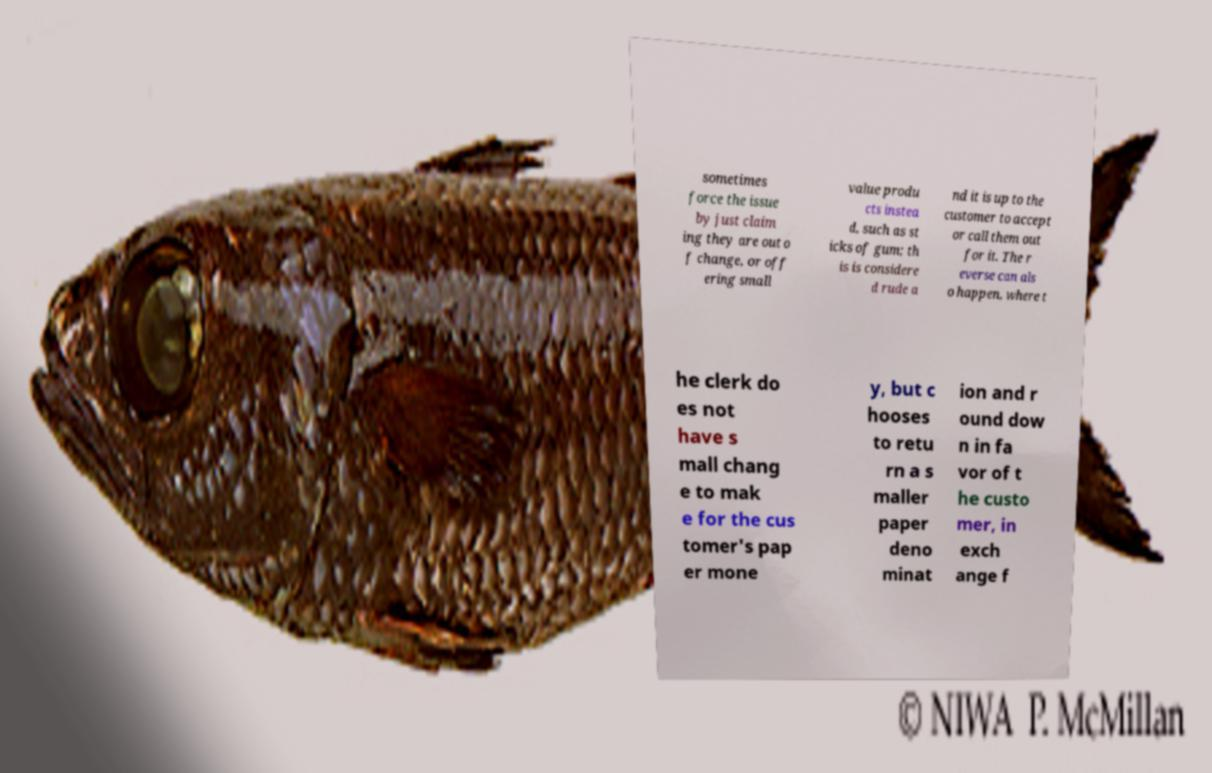Could you assist in decoding the text presented in this image and type it out clearly? sometimes force the issue by just claim ing they are out o f change, or off ering small value produ cts instea d, such as st icks of gum; th is is considere d rude a nd it is up to the customer to accept or call them out for it. The r everse can als o happen, where t he clerk do es not have s mall chang e to mak e for the cus tomer's pap er mone y, but c hooses to retu rn a s maller paper deno minat ion and r ound dow n in fa vor of t he custo mer, in exch ange f 